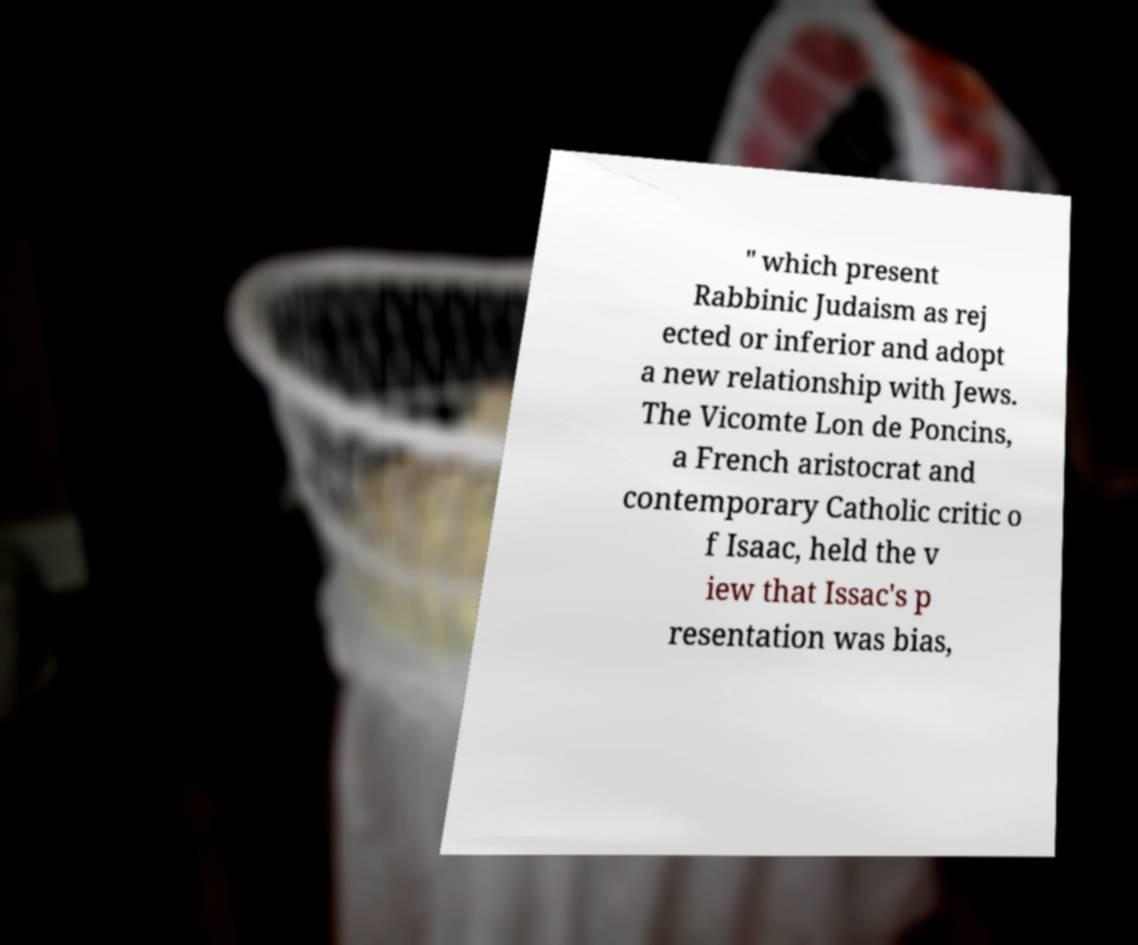Can you read and provide the text displayed in the image?This photo seems to have some interesting text. Can you extract and type it out for me? " which present Rabbinic Judaism as rej ected or inferior and adopt a new relationship with Jews. The Vicomte Lon de Poncins, a French aristocrat and contemporary Catholic critic o f Isaac, held the v iew that Issac's p resentation was bias, 